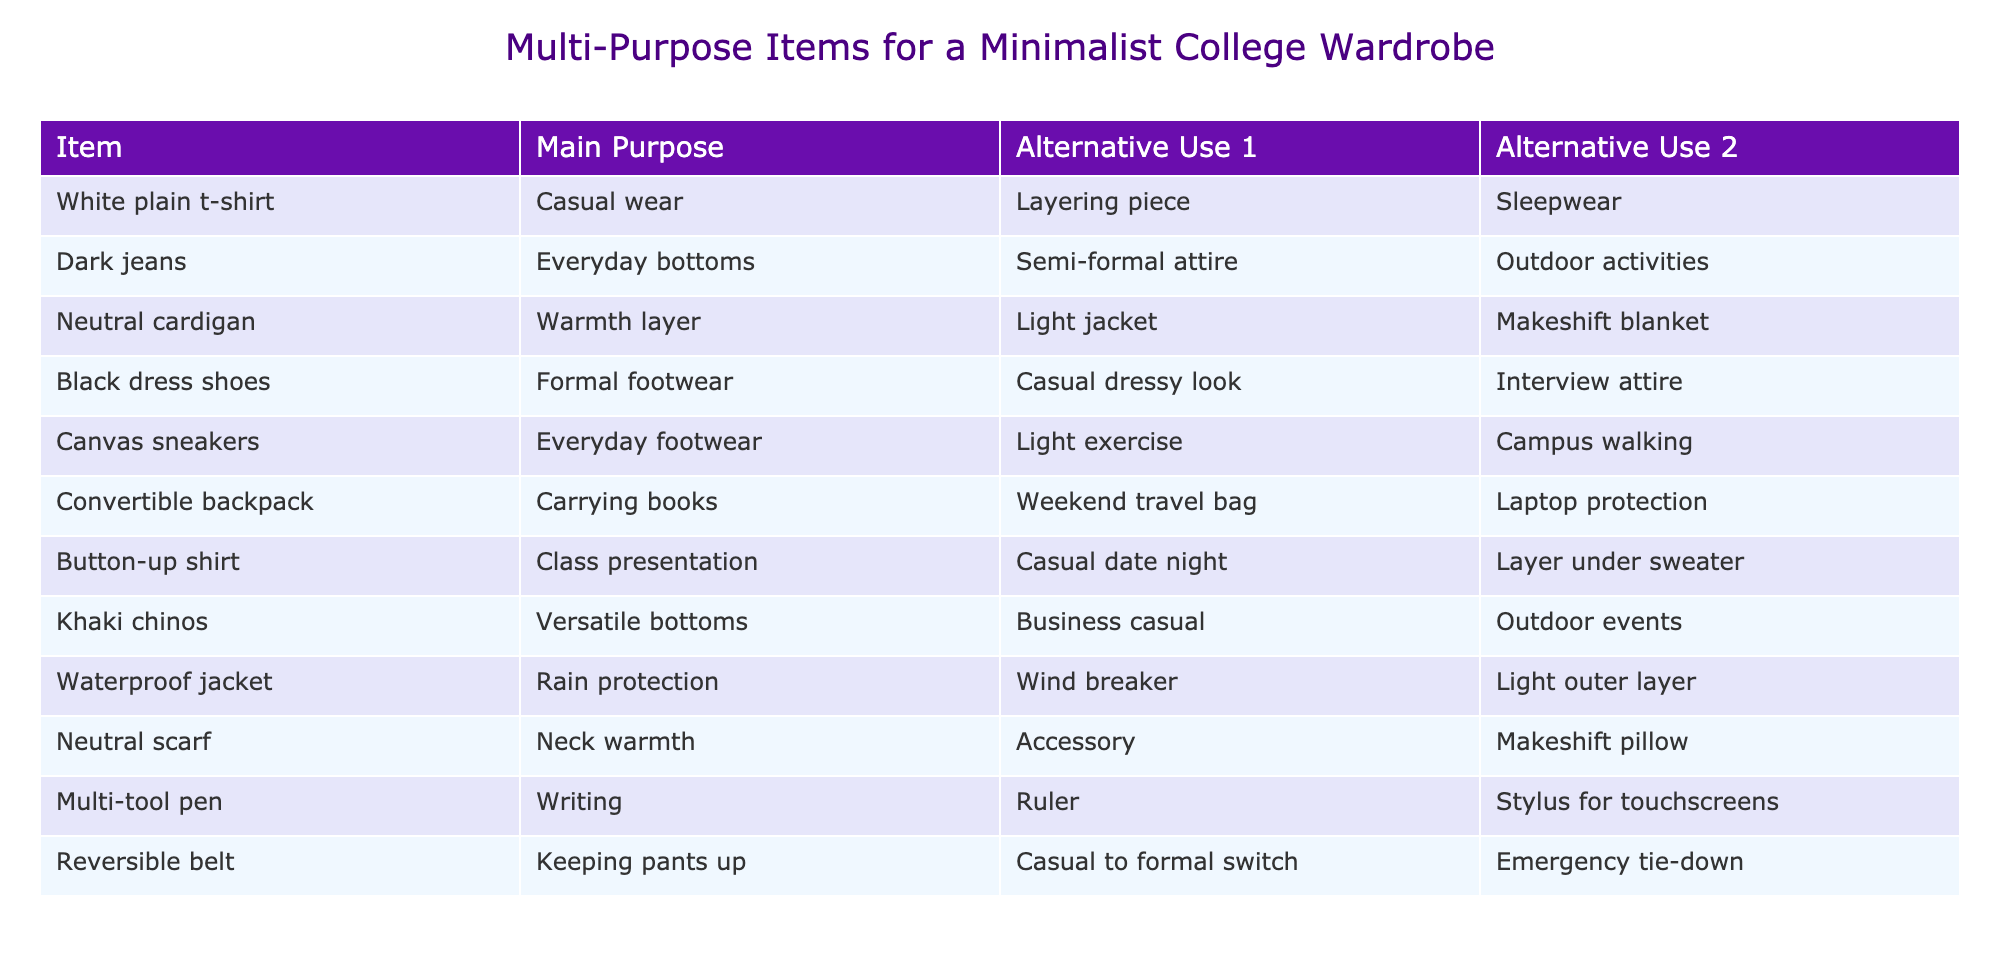What is the main purpose of the white plain t-shirt? The table indicates that the main purpose of the white plain t-shirt is casual wear, as mentioned in the corresponding row for that item.
Answer: Casual wear Which item can be used as a makeshift blanket? The neutral cardigan is listed as having a makeshift blanket as one of its alternative uses in the table.
Answer: Neutral cardigan Are dark jeans appropriate for outdoor activities? Yes, the table states that dark jeans can be used for outdoor activities, thus indicating their appropriateness for that purpose.
Answer: Yes How many items can serve as both formal footwear and casual dressy look? The table shows that black dress shoes can serve both as formal footwear and for a casual dressy look, so the total number is one.
Answer: One What items have the alternative use of providing warmth? Two items, the neutral cardigan and the neutral scarf, are noted in the table as having warmth-related alternative uses.
Answer: Two items (neutral cardigan, neutral scarf) Can the canvas sneakers be used for light exercise? Yes, according to the table, canvas sneakers are listed as an option for light exercise.
Answer: Yes Which item has the alternative use of a makeshift pillow? The neutral scarf is specifically noted in the table for its alternative use as a makeshift pillow.
Answer: Neutral scarf If you wanted a versatile bottoms option, what is a suitable item? The khaki chinos are identified in the table as versatile bottoms, making them a suitable option for that need.
Answer: Khaki chinos What would you consider the total number of items listed in the table? There are 12 items listed in the table, as the data represents each unique clothing or accessory item.
Answer: 12 items 